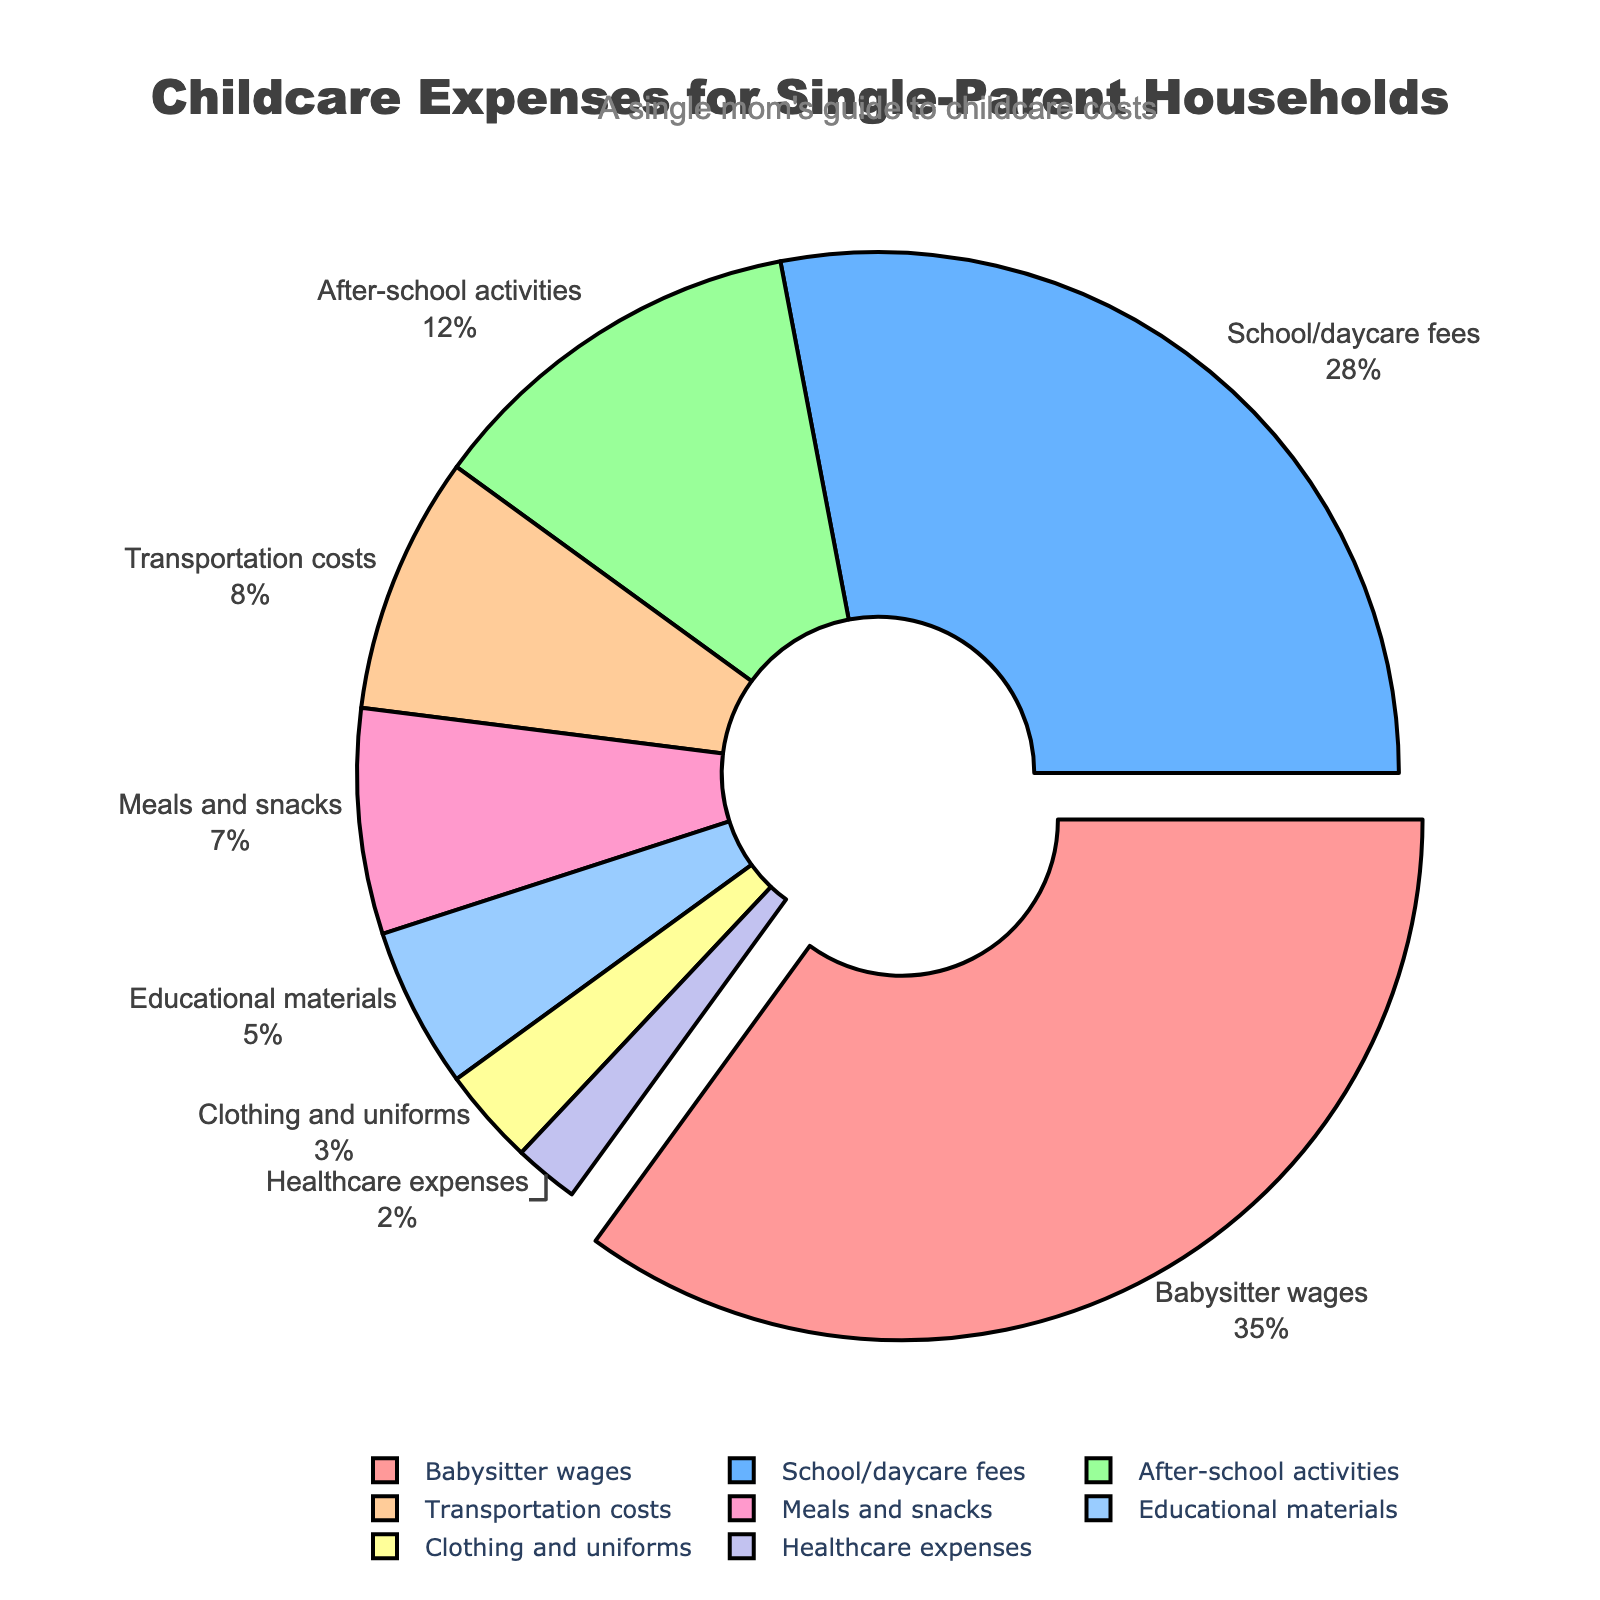Which category accounts for the highest percentage of childcare expenses? The pie chart shows that "Babysitter wages" has the largest portion among all the categories.
Answer: Babysitter wages How much more is spent on babysitter wages compared to transportation costs? Babysitter wages account for 35% and transportation costs account for 8%. The difference is 35% - 8% = 27%.
Answer: 27% Which two categories combined cover the same percentage as babysitter wages? Babysitter wages are 35%. Combining "School/daycare fees" (28%) and "Meals and snacks" (7%) gives us 28% + 7% = 35%.
Answer: School/daycare fees and Meals and snacks Which category has the smallest percentage of expenses? The pie chart shows the smallest portion belongs to "Healthcare expenses".
Answer: Healthcare expenses Are school/daycare fees more or less than after-school activities? The pie chart indicates that "School/daycare fees" are 28% while "After-school activities" are 12%, so school/daycare fees are more.
Answer: More What is the total percentage of expenses spent on educational materials and clothing/uniforms? Educational materials are 5% and clothing/uniforms are 3%. Summing them gives 5% + 3% = 8%.
Answer: 8% Which expense category shares a color similar to light blue? From a visual perspective, considering the hues mentioned, "Educational materials" (light blue) fits this description.
Answer: Educational materials Is the percentage spent on meals and snacks more than that on transportation costs? Meals and snacks account for 7% while transportation costs account for 8%. Thus, meals and snacks are less.
Answer: No What is the difference between the percentages of healthcare expenses and clothing/uniforms? Healthcare expenses are 2% and clothing/uniforms are 3%. The difference is 3% - 2% = 1%.
Answer: 1% Which category should I focus on if I want to reduce my largest expense? The largest category in the pie chart is "Babysitter wages", which should be focused on to reduce the largest expense.
Answer: Babysitter wages 